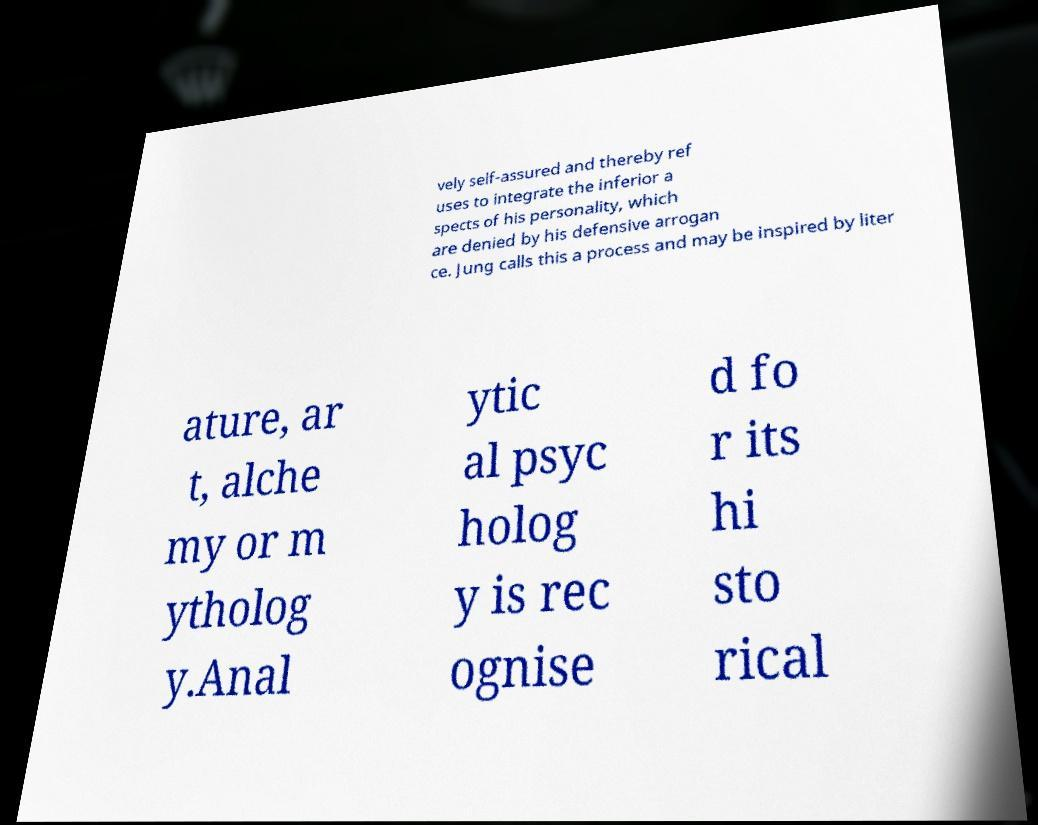Please identify and transcribe the text found in this image. vely self-assured and thereby ref uses to integrate the inferior a spects of his personality, which are denied by his defensive arrogan ce. Jung calls this a process and may be inspired by liter ature, ar t, alche my or m ytholog y.Anal ytic al psyc holog y is rec ognise d fo r its hi sto rical 